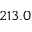Convert formula to latex. <formula><loc_0><loc_0><loc_500><loc_500>2 1 3 . 0</formula> 